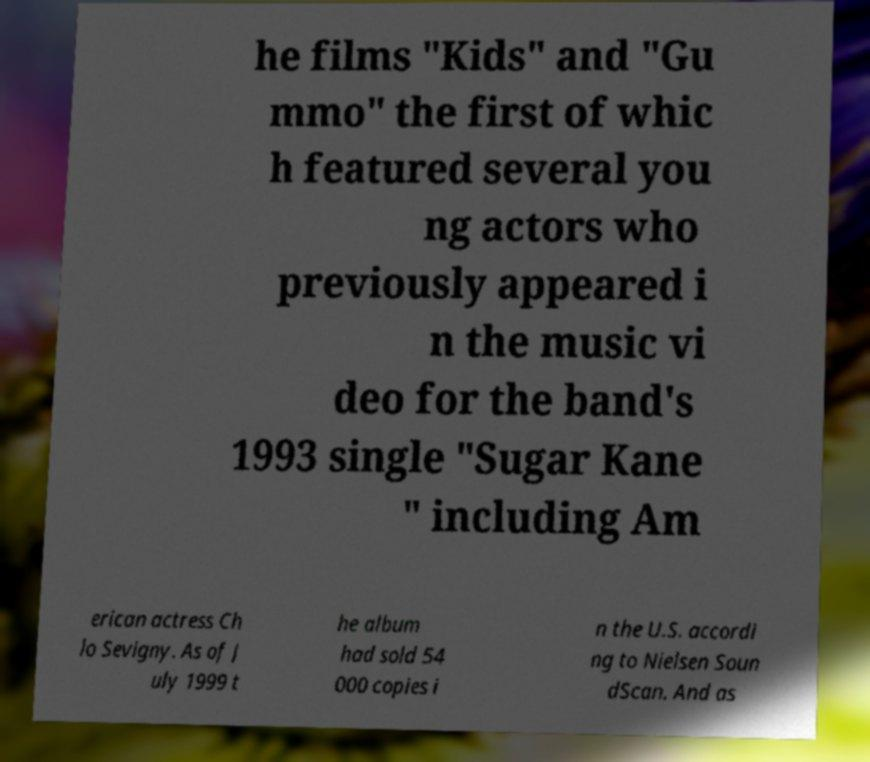Could you assist in decoding the text presented in this image and type it out clearly? he films "Kids" and "Gu mmo" the first of whic h featured several you ng actors who previously appeared i n the music vi deo for the band's 1993 single "Sugar Kane " including Am erican actress Ch lo Sevigny. As of J uly 1999 t he album had sold 54 000 copies i n the U.S. accordi ng to Nielsen Soun dScan. And as 